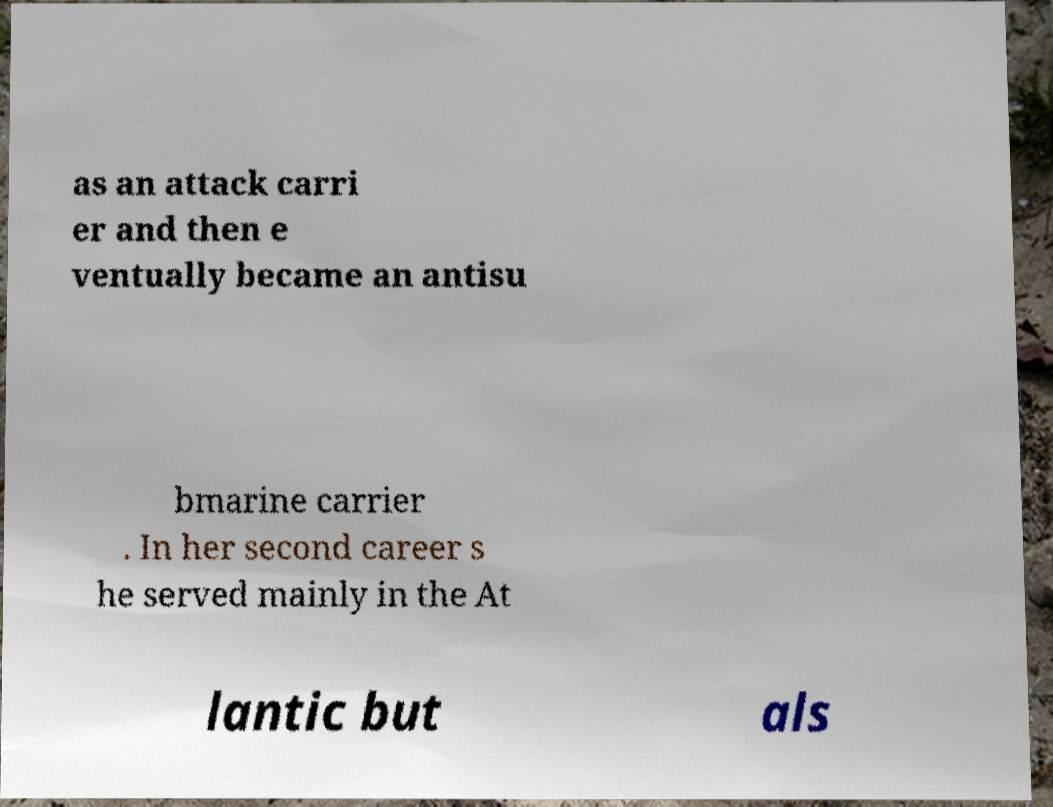Please read and relay the text visible in this image. What does it say? as an attack carri er and then e ventually became an antisu bmarine carrier . In her second career s he served mainly in the At lantic but als 